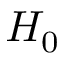Convert formula to latex. <formula><loc_0><loc_0><loc_500><loc_500>H _ { 0 }</formula> 